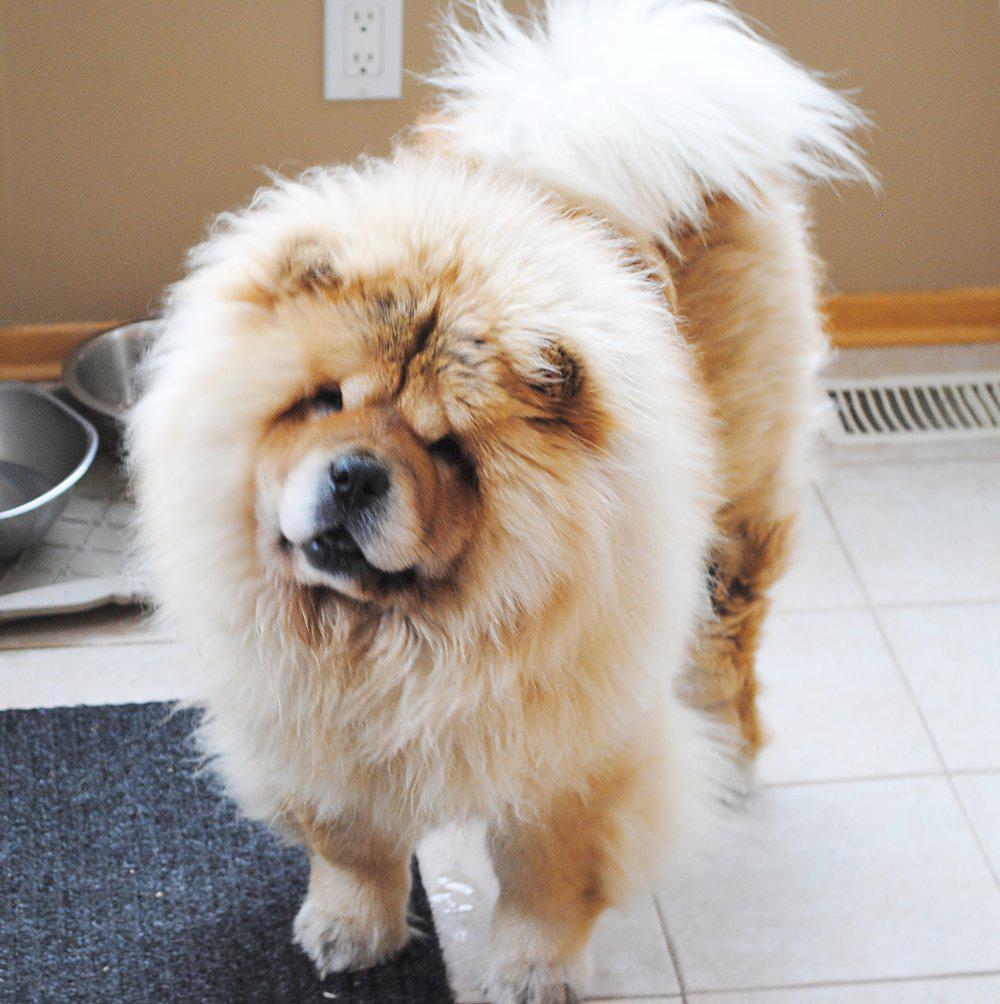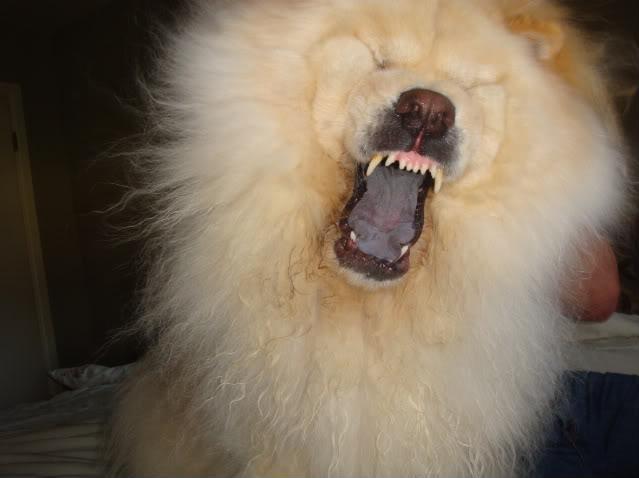The first image is the image on the left, the second image is the image on the right. Examine the images to the left and right. Is the description "The left image contains a human holding a chow dog." accurate? Answer yes or no. No. The first image is the image on the left, the second image is the image on the right. For the images shown, is this caption "The pair of pictures shows exactly two dogs and no human." true? Answer yes or no. Yes. 